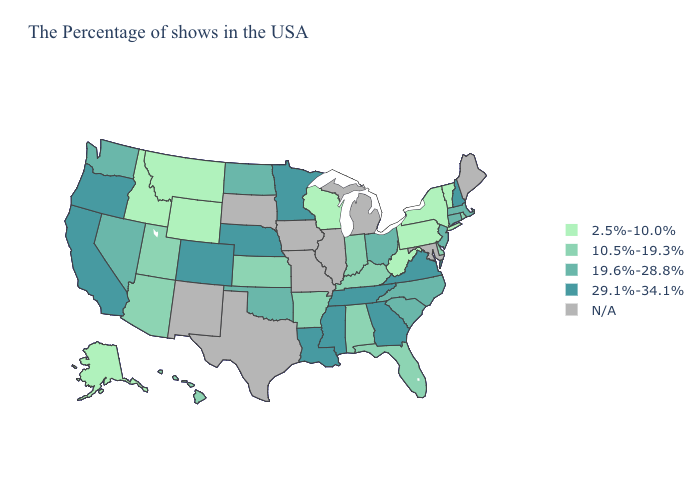Which states have the highest value in the USA?
Keep it brief. New Hampshire, Virginia, Georgia, Tennessee, Mississippi, Louisiana, Minnesota, Nebraska, Colorado, California, Oregon. Does Minnesota have the highest value in the USA?
Short answer required. Yes. Among the states that border Illinois , does Wisconsin have the lowest value?
Short answer required. Yes. Name the states that have a value in the range 29.1%-34.1%?
Quick response, please. New Hampshire, Virginia, Georgia, Tennessee, Mississippi, Louisiana, Minnesota, Nebraska, Colorado, California, Oregon. Does Nebraska have the highest value in the USA?
Answer briefly. Yes. Is the legend a continuous bar?
Be succinct. No. Name the states that have a value in the range 10.5%-19.3%?
Quick response, please. Rhode Island, Delaware, Florida, Kentucky, Indiana, Alabama, Arkansas, Kansas, Utah, Arizona, Hawaii. Name the states that have a value in the range 19.6%-28.8%?
Write a very short answer. Massachusetts, Connecticut, New Jersey, North Carolina, South Carolina, Ohio, Oklahoma, North Dakota, Nevada, Washington. Name the states that have a value in the range 29.1%-34.1%?
Quick response, please. New Hampshire, Virginia, Georgia, Tennessee, Mississippi, Louisiana, Minnesota, Nebraska, Colorado, California, Oregon. Does the first symbol in the legend represent the smallest category?
Write a very short answer. Yes. Among the states that border West Virginia , which have the highest value?
Quick response, please. Virginia. Name the states that have a value in the range 29.1%-34.1%?
Give a very brief answer. New Hampshire, Virginia, Georgia, Tennessee, Mississippi, Louisiana, Minnesota, Nebraska, Colorado, California, Oregon. Does the first symbol in the legend represent the smallest category?
Quick response, please. Yes. 